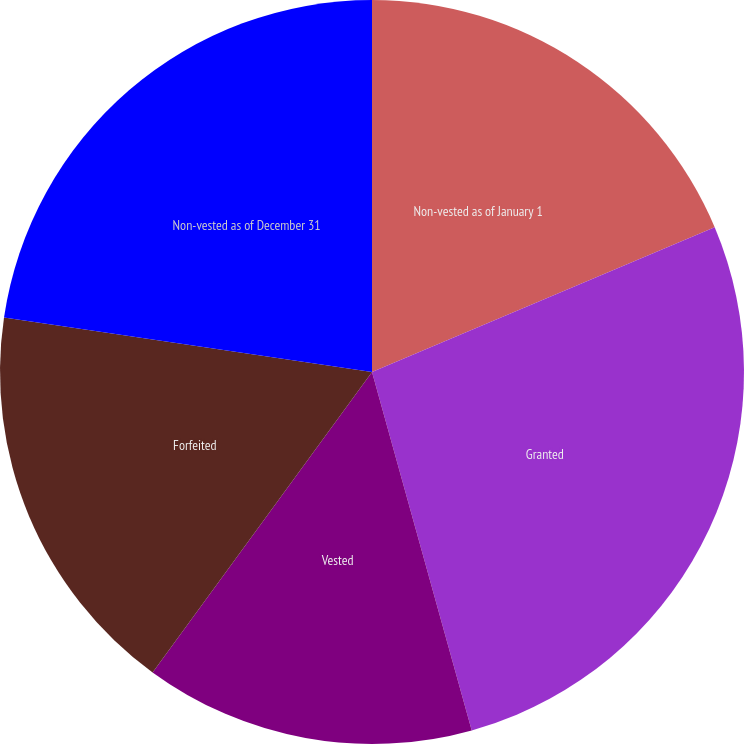<chart> <loc_0><loc_0><loc_500><loc_500><pie_chart><fcel>Non-vested as of January 1<fcel>Granted<fcel>Vested<fcel>Forfeited<fcel>Non-vested as of December 31<nl><fcel>18.64%<fcel>27.04%<fcel>14.36%<fcel>17.3%<fcel>22.66%<nl></chart> 